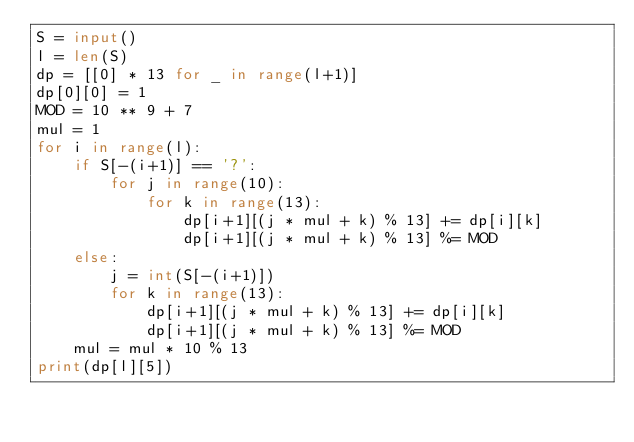Convert code to text. <code><loc_0><loc_0><loc_500><loc_500><_Python_>S = input()
l = len(S)
dp = [[0] * 13 for _ in range(l+1)]
dp[0][0] = 1
MOD = 10 ** 9 + 7
mul = 1
for i in range(l):
    if S[-(i+1)] == '?':
        for j in range(10):
            for k in range(13):
                dp[i+1][(j * mul + k) % 13] += dp[i][k]
                dp[i+1][(j * mul + k) % 13] %= MOD
    else:
        j = int(S[-(i+1)])
        for k in range(13):
            dp[i+1][(j * mul + k) % 13] += dp[i][k]
            dp[i+1][(j * mul + k) % 13] %= MOD
    mul = mul * 10 % 13
print(dp[l][5])</code> 